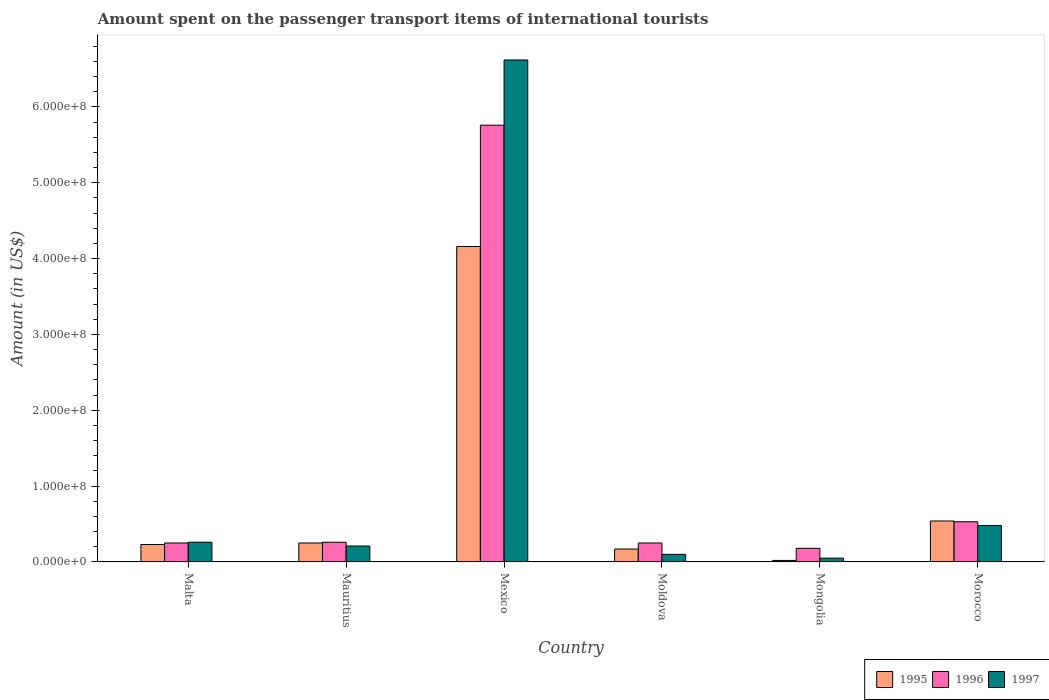How many different coloured bars are there?
Your answer should be very brief. 3. How many bars are there on the 3rd tick from the left?
Your answer should be very brief. 3. What is the label of the 1st group of bars from the left?
Provide a succinct answer. Malta. What is the amount spent on the passenger transport items of international tourists in 1996 in Malta?
Your response must be concise. 2.50e+07. Across all countries, what is the maximum amount spent on the passenger transport items of international tourists in 1997?
Keep it short and to the point. 6.62e+08. In which country was the amount spent on the passenger transport items of international tourists in 1995 maximum?
Your answer should be compact. Mexico. In which country was the amount spent on the passenger transport items of international tourists in 1997 minimum?
Make the answer very short. Mongolia. What is the total amount spent on the passenger transport items of international tourists in 1995 in the graph?
Ensure brevity in your answer.  5.37e+08. What is the difference between the amount spent on the passenger transport items of international tourists in 1996 in Malta and that in Morocco?
Ensure brevity in your answer.  -2.80e+07. What is the difference between the amount spent on the passenger transport items of international tourists in 1997 in Moldova and the amount spent on the passenger transport items of international tourists in 1996 in Mongolia?
Your answer should be very brief. -8.00e+06. What is the average amount spent on the passenger transport items of international tourists in 1997 per country?
Offer a terse response. 1.29e+08. What is the difference between the amount spent on the passenger transport items of international tourists of/in 1996 and amount spent on the passenger transport items of international tourists of/in 1995 in Morocco?
Your response must be concise. -1.00e+06. In how many countries, is the amount spent on the passenger transport items of international tourists in 1995 greater than 360000000 US$?
Give a very brief answer. 1. What is the ratio of the amount spent on the passenger transport items of international tourists in 1997 in Mexico to that in Moldova?
Keep it short and to the point. 66.2. Is the difference between the amount spent on the passenger transport items of international tourists in 1996 in Malta and Mauritius greater than the difference between the amount spent on the passenger transport items of international tourists in 1995 in Malta and Mauritius?
Ensure brevity in your answer.  Yes. What is the difference between the highest and the second highest amount spent on the passenger transport items of international tourists in 1996?
Offer a very short reply. 5.23e+08. What is the difference between the highest and the lowest amount spent on the passenger transport items of international tourists in 1996?
Give a very brief answer. 5.58e+08. In how many countries, is the amount spent on the passenger transport items of international tourists in 1996 greater than the average amount spent on the passenger transport items of international tourists in 1996 taken over all countries?
Make the answer very short. 1. Is the sum of the amount spent on the passenger transport items of international tourists in 1996 in Mongolia and Morocco greater than the maximum amount spent on the passenger transport items of international tourists in 1997 across all countries?
Offer a very short reply. No. What does the 2nd bar from the right in Morocco represents?
Give a very brief answer. 1996. Are the values on the major ticks of Y-axis written in scientific E-notation?
Keep it short and to the point. Yes. Does the graph contain grids?
Your answer should be compact. No. How many legend labels are there?
Offer a very short reply. 3. What is the title of the graph?
Your answer should be very brief. Amount spent on the passenger transport items of international tourists. What is the label or title of the Y-axis?
Your response must be concise. Amount (in US$). What is the Amount (in US$) of 1995 in Malta?
Give a very brief answer. 2.30e+07. What is the Amount (in US$) of 1996 in Malta?
Offer a terse response. 2.50e+07. What is the Amount (in US$) of 1997 in Malta?
Give a very brief answer. 2.60e+07. What is the Amount (in US$) in 1995 in Mauritius?
Offer a very short reply. 2.50e+07. What is the Amount (in US$) of 1996 in Mauritius?
Make the answer very short. 2.60e+07. What is the Amount (in US$) in 1997 in Mauritius?
Give a very brief answer. 2.10e+07. What is the Amount (in US$) of 1995 in Mexico?
Your answer should be compact. 4.16e+08. What is the Amount (in US$) of 1996 in Mexico?
Give a very brief answer. 5.76e+08. What is the Amount (in US$) in 1997 in Mexico?
Keep it short and to the point. 6.62e+08. What is the Amount (in US$) in 1995 in Moldova?
Make the answer very short. 1.70e+07. What is the Amount (in US$) in 1996 in Moldova?
Provide a short and direct response. 2.50e+07. What is the Amount (in US$) of 1996 in Mongolia?
Give a very brief answer. 1.80e+07. What is the Amount (in US$) of 1997 in Mongolia?
Make the answer very short. 5.00e+06. What is the Amount (in US$) in 1995 in Morocco?
Ensure brevity in your answer.  5.40e+07. What is the Amount (in US$) in 1996 in Morocco?
Give a very brief answer. 5.30e+07. What is the Amount (in US$) in 1997 in Morocco?
Offer a terse response. 4.80e+07. Across all countries, what is the maximum Amount (in US$) of 1995?
Make the answer very short. 4.16e+08. Across all countries, what is the maximum Amount (in US$) in 1996?
Keep it short and to the point. 5.76e+08. Across all countries, what is the maximum Amount (in US$) in 1997?
Make the answer very short. 6.62e+08. Across all countries, what is the minimum Amount (in US$) of 1996?
Offer a terse response. 1.80e+07. What is the total Amount (in US$) in 1995 in the graph?
Ensure brevity in your answer.  5.37e+08. What is the total Amount (in US$) in 1996 in the graph?
Keep it short and to the point. 7.23e+08. What is the total Amount (in US$) of 1997 in the graph?
Your answer should be compact. 7.72e+08. What is the difference between the Amount (in US$) of 1996 in Malta and that in Mauritius?
Your answer should be very brief. -1.00e+06. What is the difference between the Amount (in US$) of 1995 in Malta and that in Mexico?
Make the answer very short. -3.93e+08. What is the difference between the Amount (in US$) of 1996 in Malta and that in Mexico?
Give a very brief answer. -5.51e+08. What is the difference between the Amount (in US$) of 1997 in Malta and that in Mexico?
Give a very brief answer. -6.36e+08. What is the difference between the Amount (in US$) in 1995 in Malta and that in Moldova?
Your response must be concise. 6.00e+06. What is the difference between the Amount (in US$) in 1996 in Malta and that in Moldova?
Make the answer very short. 0. What is the difference between the Amount (in US$) in 1997 in Malta and that in Moldova?
Your answer should be very brief. 1.60e+07. What is the difference between the Amount (in US$) in 1995 in Malta and that in Mongolia?
Your response must be concise. 2.10e+07. What is the difference between the Amount (in US$) in 1996 in Malta and that in Mongolia?
Provide a short and direct response. 7.00e+06. What is the difference between the Amount (in US$) in 1997 in Malta and that in Mongolia?
Your response must be concise. 2.10e+07. What is the difference between the Amount (in US$) in 1995 in Malta and that in Morocco?
Your answer should be compact. -3.10e+07. What is the difference between the Amount (in US$) of 1996 in Malta and that in Morocco?
Give a very brief answer. -2.80e+07. What is the difference between the Amount (in US$) of 1997 in Malta and that in Morocco?
Ensure brevity in your answer.  -2.20e+07. What is the difference between the Amount (in US$) of 1995 in Mauritius and that in Mexico?
Provide a succinct answer. -3.91e+08. What is the difference between the Amount (in US$) of 1996 in Mauritius and that in Mexico?
Make the answer very short. -5.50e+08. What is the difference between the Amount (in US$) in 1997 in Mauritius and that in Mexico?
Ensure brevity in your answer.  -6.41e+08. What is the difference between the Amount (in US$) of 1997 in Mauritius and that in Moldova?
Your answer should be very brief. 1.10e+07. What is the difference between the Amount (in US$) in 1995 in Mauritius and that in Mongolia?
Keep it short and to the point. 2.30e+07. What is the difference between the Amount (in US$) in 1996 in Mauritius and that in Mongolia?
Your answer should be very brief. 8.00e+06. What is the difference between the Amount (in US$) in 1997 in Mauritius and that in Mongolia?
Keep it short and to the point. 1.60e+07. What is the difference between the Amount (in US$) in 1995 in Mauritius and that in Morocco?
Your response must be concise. -2.90e+07. What is the difference between the Amount (in US$) of 1996 in Mauritius and that in Morocco?
Keep it short and to the point. -2.70e+07. What is the difference between the Amount (in US$) of 1997 in Mauritius and that in Morocco?
Your answer should be very brief. -2.70e+07. What is the difference between the Amount (in US$) of 1995 in Mexico and that in Moldova?
Your answer should be very brief. 3.99e+08. What is the difference between the Amount (in US$) in 1996 in Mexico and that in Moldova?
Keep it short and to the point. 5.51e+08. What is the difference between the Amount (in US$) in 1997 in Mexico and that in Moldova?
Offer a terse response. 6.52e+08. What is the difference between the Amount (in US$) of 1995 in Mexico and that in Mongolia?
Your answer should be compact. 4.14e+08. What is the difference between the Amount (in US$) of 1996 in Mexico and that in Mongolia?
Make the answer very short. 5.58e+08. What is the difference between the Amount (in US$) of 1997 in Mexico and that in Mongolia?
Your response must be concise. 6.57e+08. What is the difference between the Amount (in US$) of 1995 in Mexico and that in Morocco?
Your response must be concise. 3.62e+08. What is the difference between the Amount (in US$) of 1996 in Mexico and that in Morocco?
Your response must be concise. 5.23e+08. What is the difference between the Amount (in US$) in 1997 in Mexico and that in Morocco?
Provide a short and direct response. 6.14e+08. What is the difference between the Amount (in US$) in 1995 in Moldova and that in Mongolia?
Make the answer very short. 1.50e+07. What is the difference between the Amount (in US$) of 1997 in Moldova and that in Mongolia?
Provide a succinct answer. 5.00e+06. What is the difference between the Amount (in US$) of 1995 in Moldova and that in Morocco?
Give a very brief answer. -3.70e+07. What is the difference between the Amount (in US$) of 1996 in Moldova and that in Morocco?
Make the answer very short. -2.80e+07. What is the difference between the Amount (in US$) in 1997 in Moldova and that in Morocco?
Ensure brevity in your answer.  -3.80e+07. What is the difference between the Amount (in US$) in 1995 in Mongolia and that in Morocco?
Make the answer very short. -5.20e+07. What is the difference between the Amount (in US$) of 1996 in Mongolia and that in Morocco?
Ensure brevity in your answer.  -3.50e+07. What is the difference between the Amount (in US$) in 1997 in Mongolia and that in Morocco?
Make the answer very short. -4.30e+07. What is the difference between the Amount (in US$) in 1995 in Malta and the Amount (in US$) in 1996 in Mauritius?
Ensure brevity in your answer.  -3.00e+06. What is the difference between the Amount (in US$) of 1995 in Malta and the Amount (in US$) of 1997 in Mauritius?
Offer a terse response. 2.00e+06. What is the difference between the Amount (in US$) in 1996 in Malta and the Amount (in US$) in 1997 in Mauritius?
Your answer should be compact. 4.00e+06. What is the difference between the Amount (in US$) in 1995 in Malta and the Amount (in US$) in 1996 in Mexico?
Offer a very short reply. -5.53e+08. What is the difference between the Amount (in US$) in 1995 in Malta and the Amount (in US$) in 1997 in Mexico?
Give a very brief answer. -6.39e+08. What is the difference between the Amount (in US$) of 1996 in Malta and the Amount (in US$) of 1997 in Mexico?
Your answer should be very brief. -6.37e+08. What is the difference between the Amount (in US$) of 1995 in Malta and the Amount (in US$) of 1996 in Moldova?
Give a very brief answer. -2.00e+06. What is the difference between the Amount (in US$) in 1995 in Malta and the Amount (in US$) in 1997 in Moldova?
Offer a terse response. 1.30e+07. What is the difference between the Amount (in US$) in 1996 in Malta and the Amount (in US$) in 1997 in Moldova?
Ensure brevity in your answer.  1.50e+07. What is the difference between the Amount (in US$) in 1995 in Malta and the Amount (in US$) in 1996 in Mongolia?
Offer a very short reply. 5.00e+06. What is the difference between the Amount (in US$) in 1995 in Malta and the Amount (in US$) in 1997 in Mongolia?
Your response must be concise. 1.80e+07. What is the difference between the Amount (in US$) of 1995 in Malta and the Amount (in US$) of 1996 in Morocco?
Ensure brevity in your answer.  -3.00e+07. What is the difference between the Amount (in US$) in 1995 in Malta and the Amount (in US$) in 1997 in Morocco?
Your response must be concise. -2.50e+07. What is the difference between the Amount (in US$) in 1996 in Malta and the Amount (in US$) in 1997 in Morocco?
Provide a short and direct response. -2.30e+07. What is the difference between the Amount (in US$) of 1995 in Mauritius and the Amount (in US$) of 1996 in Mexico?
Keep it short and to the point. -5.51e+08. What is the difference between the Amount (in US$) in 1995 in Mauritius and the Amount (in US$) in 1997 in Mexico?
Keep it short and to the point. -6.37e+08. What is the difference between the Amount (in US$) in 1996 in Mauritius and the Amount (in US$) in 1997 in Mexico?
Your response must be concise. -6.36e+08. What is the difference between the Amount (in US$) of 1995 in Mauritius and the Amount (in US$) of 1997 in Moldova?
Keep it short and to the point. 1.50e+07. What is the difference between the Amount (in US$) of 1996 in Mauritius and the Amount (in US$) of 1997 in Moldova?
Offer a very short reply. 1.60e+07. What is the difference between the Amount (in US$) of 1995 in Mauritius and the Amount (in US$) of 1996 in Mongolia?
Give a very brief answer. 7.00e+06. What is the difference between the Amount (in US$) of 1996 in Mauritius and the Amount (in US$) of 1997 in Mongolia?
Offer a terse response. 2.10e+07. What is the difference between the Amount (in US$) in 1995 in Mauritius and the Amount (in US$) in 1996 in Morocco?
Your answer should be compact. -2.80e+07. What is the difference between the Amount (in US$) of 1995 in Mauritius and the Amount (in US$) of 1997 in Morocco?
Offer a terse response. -2.30e+07. What is the difference between the Amount (in US$) in 1996 in Mauritius and the Amount (in US$) in 1997 in Morocco?
Offer a terse response. -2.20e+07. What is the difference between the Amount (in US$) of 1995 in Mexico and the Amount (in US$) of 1996 in Moldova?
Your response must be concise. 3.91e+08. What is the difference between the Amount (in US$) of 1995 in Mexico and the Amount (in US$) of 1997 in Moldova?
Ensure brevity in your answer.  4.06e+08. What is the difference between the Amount (in US$) in 1996 in Mexico and the Amount (in US$) in 1997 in Moldova?
Ensure brevity in your answer.  5.66e+08. What is the difference between the Amount (in US$) in 1995 in Mexico and the Amount (in US$) in 1996 in Mongolia?
Your response must be concise. 3.98e+08. What is the difference between the Amount (in US$) in 1995 in Mexico and the Amount (in US$) in 1997 in Mongolia?
Your answer should be very brief. 4.11e+08. What is the difference between the Amount (in US$) in 1996 in Mexico and the Amount (in US$) in 1997 in Mongolia?
Your answer should be compact. 5.71e+08. What is the difference between the Amount (in US$) in 1995 in Mexico and the Amount (in US$) in 1996 in Morocco?
Offer a very short reply. 3.63e+08. What is the difference between the Amount (in US$) of 1995 in Mexico and the Amount (in US$) of 1997 in Morocco?
Ensure brevity in your answer.  3.68e+08. What is the difference between the Amount (in US$) in 1996 in Mexico and the Amount (in US$) in 1997 in Morocco?
Keep it short and to the point. 5.28e+08. What is the difference between the Amount (in US$) of 1996 in Moldova and the Amount (in US$) of 1997 in Mongolia?
Provide a succinct answer. 2.00e+07. What is the difference between the Amount (in US$) in 1995 in Moldova and the Amount (in US$) in 1996 in Morocco?
Provide a short and direct response. -3.60e+07. What is the difference between the Amount (in US$) of 1995 in Moldova and the Amount (in US$) of 1997 in Morocco?
Offer a terse response. -3.10e+07. What is the difference between the Amount (in US$) in 1996 in Moldova and the Amount (in US$) in 1997 in Morocco?
Keep it short and to the point. -2.30e+07. What is the difference between the Amount (in US$) of 1995 in Mongolia and the Amount (in US$) of 1996 in Morocco?
Your answer should be compact. -5.10e+07. What is the difference between the Amount (in US$) in 1995 in Mongolia and the Amount (in US$) in 1997 in Morocco?
Give a very brief answer. -4.60e+07. What is the difference between the Amount (in US$) in 1996 in Mongolia and the Amount (in US$) in 1997 in Morocco?
Your answer should be compact. -3.00e+07. What is the average Amount (in US$) of 1995 per country?
Offer a terse response. 8.95e+07. What is the average Amount (in US$) in 1996 per country?
Make the answer very short. 1.20e+08. What is the average Amount (in US$) of 1997 per country?
Make the answer very short. 1.29e+08. What is the difference between the Amount (in US$) in 1995 and Amount (in US$) in 1997 in Malta?
Give a very brief answer. -3.00e+06. What is the difference between the Amount (in US$) of 1996 and Amount (in US$) of 1997 in Malta?
Your answer should be very brief. -1.00e+06. What is the difference between the Amount (in US$) in 1995 and Amount (in US$) in 1996 in Mauritius?
Provide a short and direct response. -1.00e+06. What is the difference between the Amount (in US$) in 1995 and Amount (in US$) in 1996 in Mexico?
Provide a succinct answer. -1.60e+08. What is the difference between the Amount (in US$) in 1995 and Amount (in US$) in 1997 in Mexico?
Offer a very short reply. -2.46e+08. What is the difference between the Amount (in US$) in 1996 and Amount (in US$) in 1997 in Mexico?
Ensure brevity in your answer.  -8.60e+07. What is the difference between the Amount (in US$) of 1995 and Amount (in US$) of 1996 in Moldova?
Your answer should be compact. -8.00e+06. What is the difference between the Amount (in US$) in 1995 and Amount (in US$) in 1997 in Moldova?
Give a very brief answer. 7.00e+06. What is the difference between the Amount (in US$) of 1996 and Amount (in US$) of 1997 in Moldova?
Your answer should be very brief. 1.50e+07. What is the difference between the Amount (in US$) in 1995 and Amount (in US$) in 1996 in Mongolia?
Ensure brevity in your answer.  -1.60e+07. What is the difference between the Amount (in US$) of 1995 and Amount (in US$) of 1997 in Mongolia?
Your answer should be compact. -3.00e+06. What is the difference between the Amount (in US$) of 1996 and Amount (in US$) of 1997 in Mongolia?
Your answer should be compact. 1.30e+07. What is the difference between the Amount (in US$) of 1995 and Amount (in US$) of 1997 in Morocco?
Your answer should be compact. 6.00e+06. What is the difference between the Amount (in US$) of 1996 and Amount (in US$) of 1997 in Morocco?
Offer a very short reply. 5.00e+06. What is the ratio of the Amount (in US$) of 1996 in Malta to that in Mauritius?
Keep it short and to the point. 0.96. What is the ratio of the Amount (in US$) of 1997 in Malta to that in Mauritius?
Offer a terse response. 1.24. What is the ratio of the Amount (in US$) of 1995 in Malta to that in Mexico?
Keep it short and to the point. 0.06. What is the ratio of the Amount (in US$) of 1996 in Malta to that in Mexico?
Your response must be concise. 0.04. What is the ratio of the Amount (in US$) in 1997 in Malta to that in Mexico?
Offer a very short reply. 0.04. What is the ratio of the Amount (in US$) in 1995 in Malta to that in Moldova?
Your answer should be compact. 1.35. What is the ratio of the Amount (in US$) of 1996 in Malta to that in Moldova?
Offer a terse response. 1. What is the ratio of the Amount (in US$) in 1995 in Malta to that in Mongolia?
Keep it short and to the point. 11.5. What is the ratio of the Amount (in US$) in 1996 in Malta to that in Mongolia?
Offer a terse response. 1.39. What is the ratio of the Amount (in US$) in 1995 in Malta to that in Morocco?
Your answer should be compact. 0.43. What is the ratio of the Amount (in US$) in 1996 in Malta to that in Morocco?
Your response must be concise. 0.47. What is the ratio of the Amount (in US$) in 1997 in Malta to that in Morocco?
Offer a very short reply. 0.54. What is the ratio of the Amount (in US$) in 1995 in Mauritius to that in Mexico?
Your response must be concise. 0.06. What is the ratio of the Amount (in US$) of 1996 in Mauritius to that in Mexico?
Ensure brevity in your answer.  0.05. What is the ratio of the Amount (in US$) of 1997 in Mauritius to that in Mexico?
Your response must be concise. 0.03. What is the ratio of the Amount (in US$) in 1995 in Mauritius to that in Moldova?
Give a very brief answer. 1.47. What is the ratio of the Amount (in US$) of 1996 in Mauritius to that in Moldova?
Keep it short and to the point. 1.04. What is the ratio of the Amount (in US$) of 1997 in Mauritius to that in Moldova?
Your response must be concise. 2.1. What is the ratio of the Amount (in US$) of 1995 in Mauritius to that in Mongolia?
Provide a succinct answer. 12.5. What is the ratio of the Amount (in US$) of 1996 in Mauritius to that in Mongolia?
Offer a terse response. 1.44. What is the ratio of the Amount (in US$) in 1997 in Mauritius to that in Mongolia?
Offer a terse response. 4.2. What is the ratio of the Amount (in US$) of 1995 in Mauritius to that in Morocco?
Your answer should be compact. 0.46. What is the ratio of the Amount (in US$) in 1996 in Mauritius to that in Morocco?
Give a very brief answer. 0.49. What is the ratio of the Amount (in US$) in 1997 in Mauritius to that in Morocco?
Offer a very short reply. 0.44. What is the ratio of the Amount (in US$) of 1995 in Mexico to that in Moldova?
Ensure brevity in your answer.  24.47. What is the ratio of the Amount (in US$) of 1996 in Mexico to that in Moldova?
Offer a terse response. 23.04. What is the ratio of the Amount (in US$) of 1997 in Mexico to that in Moldova?
Offer a very short reply. 66.2. What is the ratio of the Amount (in US$) in 1995 in Mexico to that in Mongolia?
Provide a short and direct response. 208. What is the ratio of the Amount (in US$) in 1997 in Mexico to that in Mongolia?
Ensure brevity in your answer.  132.4. What is the ratio of the Amount (in US$) of 1995 in Mexico to that in Morocco?
Offer a very short reply. 7.7. What is the ratio of the Amount (in US$) in 1996 in Mexico to that in Morocco?
Your answer should be very brief. 10.87. What is the ratio of the Amount (in US$) in 1997 in Mexico to that in Morocco?
Your answer should be very brief. 13.79. What is the ratio of the Amount (in US$) in 1996 in Moldova to that in Mongolia?
Your answer should be very brief. 1.39. What is the ratio of the Amount (in US$) in 1995 in Moldova to that in Morocco?
Provide a short and direct response. 0.31. What is the ratio of the Amount (in US$) in 1996 in Moldova to that in Morocco?
Keep it short and to the point. 0.47. What is the ratio of the Amount (in US$) in 1997 in Moldova to that in Morocco?
Your answer should be very brief. 0.21. What is the ratio of the Amount (in US$) of 1995 in Mongolia to that in Morocco?
Offer a terse response. 0.04. What is the ratio of the Amount (in US$) of 1996 in Mongolia to that in Morocco?
Offer a very short reply. 0.34. What is the ratio of the Amount (in US$) of 1997 in Mongolia to that in Morocco?
Ensure brevity in your answer.  0.1. What is the difference between the highest and the second highest Amount (in US$) of 1995?
Your response must be concise. 3.62e+08. What is the difference between the highest and the second highest Amount (in US$) in 1996?
Ensure brevity in your answer.  5.23e+08. What is the difference between the highest and the second highest Amount (in US$) in 1997?
Provide a succinct answer. 6.14e+08. What is the difference between the highest and the lowest Amount (in US$) of 1995?
Make the answer very short. 4.14e+08. What is the difference between the highest and the lowest Amount (in US$) of 1996?
Your response must be concise. 5.58e+08. What is the difference between the highest and the lowest Amount (in US$) of 1997?
Provide a short and direct response. 6.57e+08. 